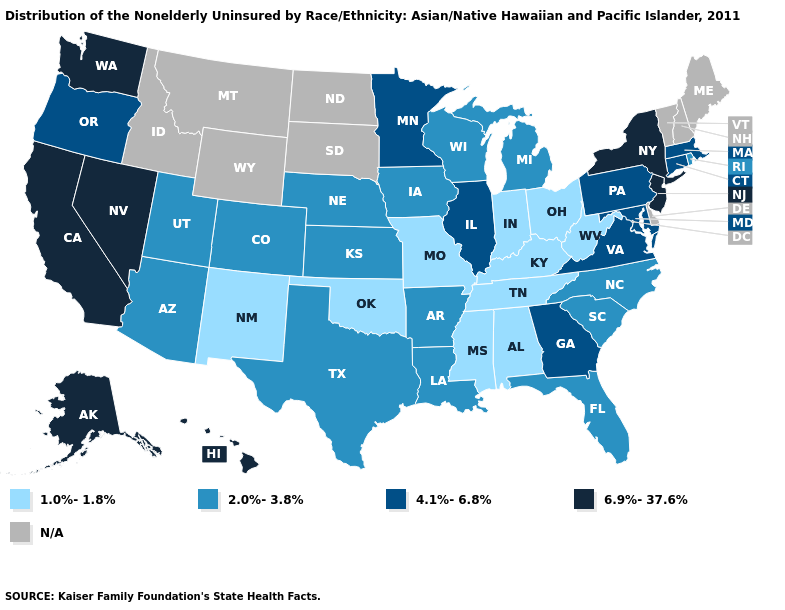Does Tennessee have the lowest value in the USA?
Quick response, please. Yes. What is the highest value in the USA?
Write a very short answer. 6.9%-37.6%. Among the states that border Nevada , which have the lowest value?
Write a very short answer. Arizona, Utah. Which states have the lowest value in the USA?
Be succinct. Alabama, Indiana, Kentucky, Mississippi, Missouri, New Mexico, Ohio, Oklahoma, Tennessee, West Virginia. What is the lowest value in the West?
Answer briefly. 1.0%-1.8%. What is the value of New Jersey?
Concise answer only. 6.9%-37.6%. Name the states that have a value in the range 4.1%-6.8%?
Keep it brief. Connecticut, Georgia, Illinois, Maryland, Massachusetts, Minnesota, Oregon, Pennsylvania, Virginia. What is the lowest value in the West?
Be succinct. 1.0%-1.8%. Does the map have missing data?
Write a very short answer. Yes. What is the lowest value in the USA?
Keep it brief. 1.0%-1.8%. What is the highest value in the Northeast ?
Keep it brief. 6.9%-37.6%. What is the value of Louisiana?
Answer briefly. 2.0%-3.8%. How many symbols are there in the legend?
Answer briefly. 5. Which states hav the highest value in the MidWest?
Give a very brief answer. Illinois, Minnesota. What is the value of Alaska?
Keep it brief. 6.9%-37.6%. 